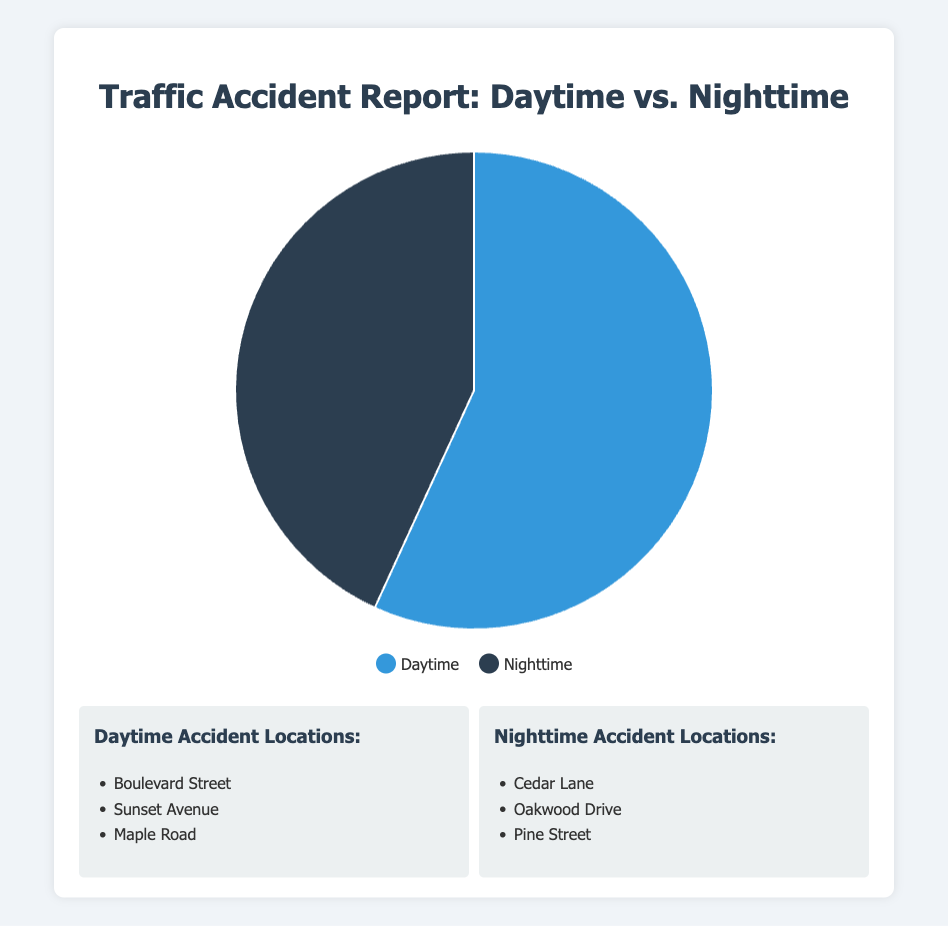How many more accidents are reported during the daytime compared to nighttime? To find the difference, subtract the number of nighttime accidents from the daytime accidents: 1250 - 950 = 300
Answer: 300 What percentage of the total accidents occur at night? To find the percentage, divide the number of nighttime accidents by the total number of accidents and multiply by 100: (950 / (1250 + 950)) * 100 = 43.18%
Answer: 43.18% Which time period has a higher number of accidents reported? Compare the number of accidents reported during daytime (1250) and nighttime (950). Daytime has a higher number of accidents.
Answer: Daytime What is the ratio of daytime to nighttime accidents? The ratio is found by dividing the number of daytime accidents by the number of nighttime accidents: 1250 / 950 ≈ 1.32
Answer: 1.32 How many accidents are reported in total? Sum the number of accidents reported during both daytime and nighttime: 1250 + 950 = 2200
Answer: 2200 What fraction of accidents occur during the daytime? To find the fraction, divide the number of daytime accidents by the total number of accidents: 1250 / 2200 = 0.568
Answer: 0.568 What are the three example locations for nighttime accidents as per the figure? The nighttime accident examples listed are Cedar Lane, Oakwood Drive, and Pine Street.
Answer: Cedar Lane, Oakwood Drive, Pine Street Which color in the chart represents nighttime accidents? The legend indicates that the color representing nighttime accidents in the pie chart is dark blue.
Answer: Dark blue If the number of nighttime accidents increased by 10%, how many nighttime accidents would there be? First, calculate 10% of nighttime accidents: 950 * 0.10 = 95. Then, add this to the original number: 950 + 95 = 1045
Answer: 1045 What are some of the streets with reported daytime accidents mentioned in the figure? The daytime accident locations provided are Boulevard Street, Sunset Avenue, and Maple Road.
Answer: Boulevard Street, Sunset Avenue, Maple Road 